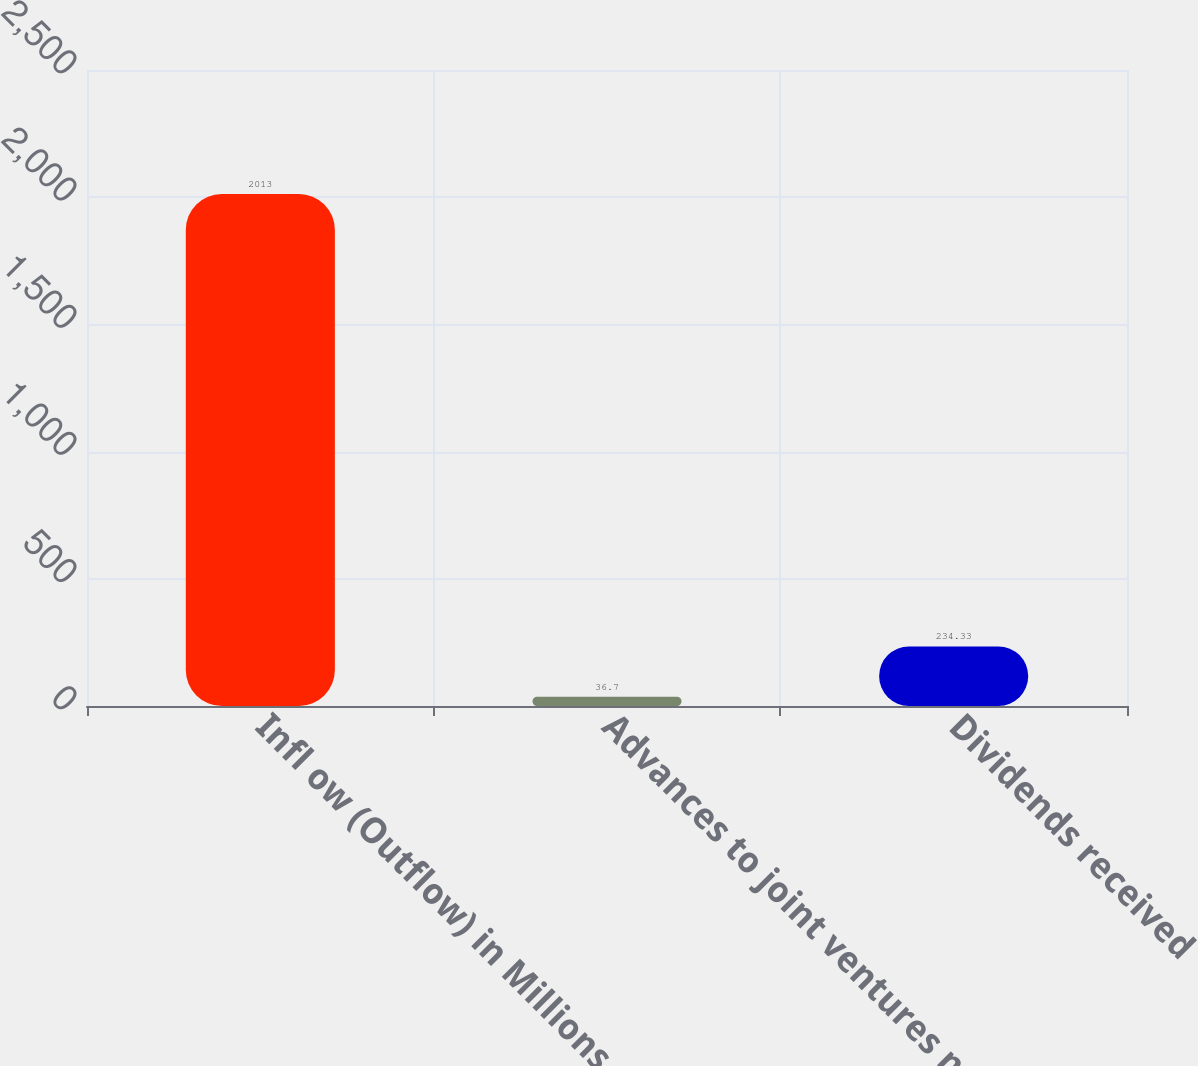Convert chart to OTSL. <chart><loc_0><loc_0><loc_500><loc_500><bar_chart><fcel>Infl ow (Outflow) in Millions<fcel>Advances to joint ventures net<fcel>Dividends received<nl><fcel>2013<fcel>36.7<fcel>234.33<nl></chart> 